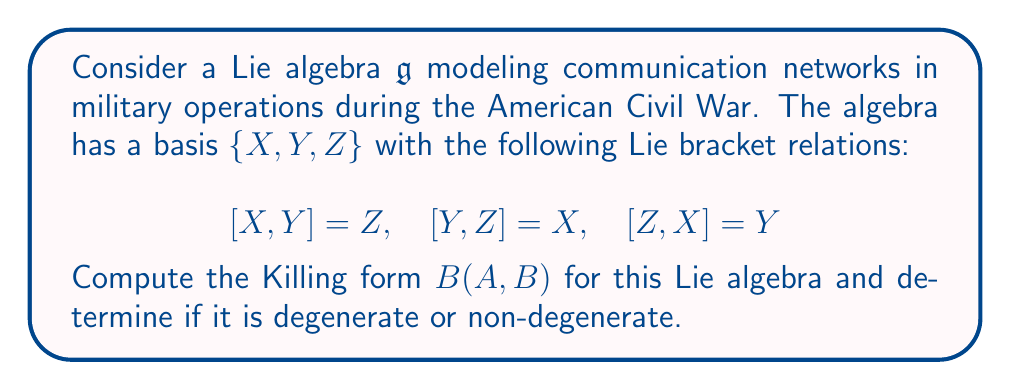Could you help me with this problem? To solve this problem, we'll follow these steps:

1) The Killing form $B(A,B)$ for a Lie algebra is defined as:

   $$B(A,B) = \text{tr}(\text{ad}(A) \circ \text{ad}(B))$$

   where $\text{ad}(A)$ is the adjoint representation of $A$.

2) We need to calculate $\text{ad}(X)$, $\text{ad}(Y)$, and $\text{ad}(Z)$ in matrix form:

   $$\text{ad}(X) = \begin{pmatrix}
   0 & 0 & -1 \\
   0 & 0 & 0 \\
   0 & 1 & 0
   \end{pmatrix}$$

   $$\text{ad}(Y) = \begin{pmatrix}
   0 & 0 & 0 \\
   0 & 0 & -1 \\
   1 & 0 & 0
   \end{pmatrix}$$

   $$\text{ad}(Z) = \begin{pmatrix}
   0 & -1 & 0 \\
   1 & 0 & 0 \\
   0 & 0 & 0
   \end{pmatrix}$$

3) Now, we calculate $B(X,X)$, $B(Y,Y)$, $B(Z,Z)$, $B(X,Y)$, $B(Y,Z)$, and $B(X,Z)$:

   $$B(X,X) = \text{tr}(\text{ad}(X) \circ \text{ad}(X)) = -2$$
   $$B(Y,Y) = \text{tr}(\text{ad}(Y) \circ \text{ad}(Y)) = -2$$
   $$B(Z,Z) = \text{tr}(\text{ad}(Z) \circ \text{ad}(Z)) = -2$$
   $$B(X,Y) = B(Y,X) = \text{tr}(\text{ad}(X) \circ \text{ad}(Y)) = 0$$
   $$B(Y,Z) = B(Z,Y) = \text{tr}(\text{ad}(Y) \circ \text{ad}(Z)) = 0$$
   $$B(X,Z) = B(Z,X) = \text{tr}(\text{ad}(X) \circ \text{ad}(Z)) = 0$$

4) The Killing form can be represented as a matrix:

   $$B = \begin{pmatrix}
   -2 & 0 & 0 \\
   0 & -2 & 0 \\
   0 & 0 & -2
   \end{pmatrix}$$

5) To determine if the Killing form is degenerate or non-degenerate, we calculate its determinant:

   $$\det(B) = (-2)^3 = -8 \neq 0$$

   Since the determinant is non-zero, the Killing form is non-degenerate.
Answer: The Killing form for the given Lie algebra is:

$$B = \begin{pmatrix}
-2 & 0 & 0 \\
0 & -2 & 0 \\
0 & 0 & -2
\end{pmatrix}$$

The Killing form is non-degenerate as $\det(B) = -8 \neq 0$. 